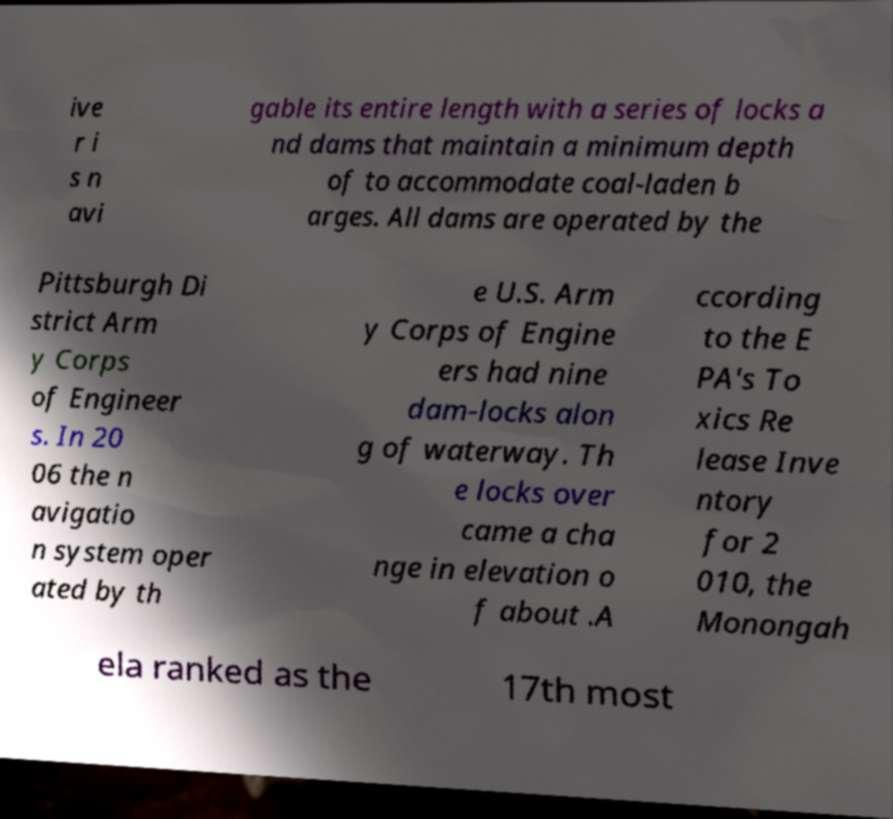Can you read and provide the text displayed in the image?This photo seems to have some interesting text. Can you extract and type it out for me? ive r i s n avi gable its entire length with a series of locks a nd dams that maintain a minimum depth of to accommodate coal-laden b arges. All dams are operated by the Pittsburgh Di strict Arm y Corps of Engineer s. In 20 06 the n avigatio n system oper ated by th e U.S. Arm y Corps of Engine ers had nine dam-locks alon g of waterway. Th e locks over came a cha nge in elevation o f about .A ccording to the E PA's To xics Re lease Inve ntory for 2 010, the Monongah ela ranked as the 17th most 